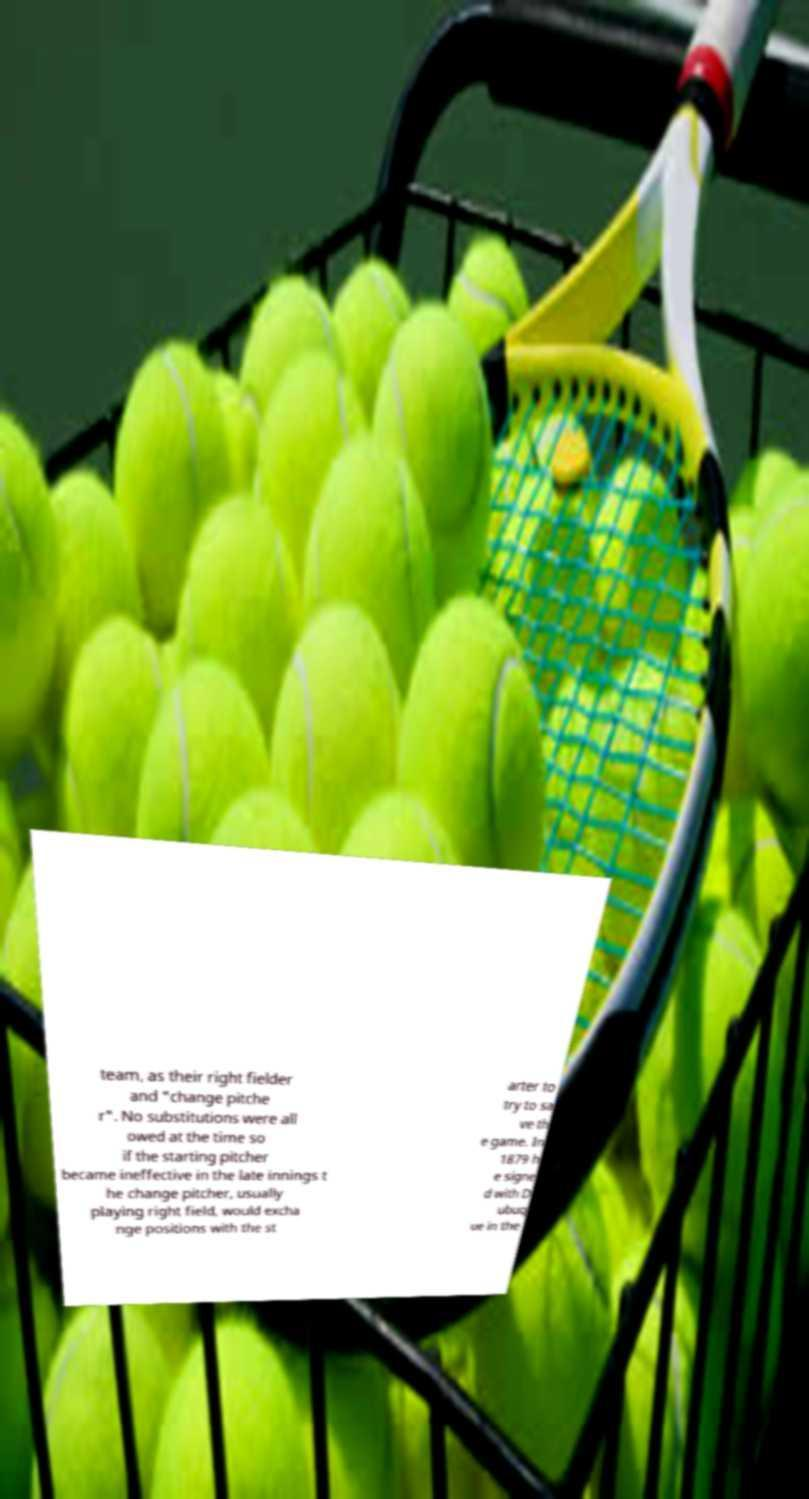Could you assist in decoding the text presented in this image and type it out clearly? team, as their right fielder and "change pitche r". No substitutions were all owed at the time so if the starting pitcher became ineffective in the late innings t he change pitcher, usually playing right field, would excha nge positions with the st arter to try to sa ve th e game. In 1879 h e signe d with D ubuq ue in the 